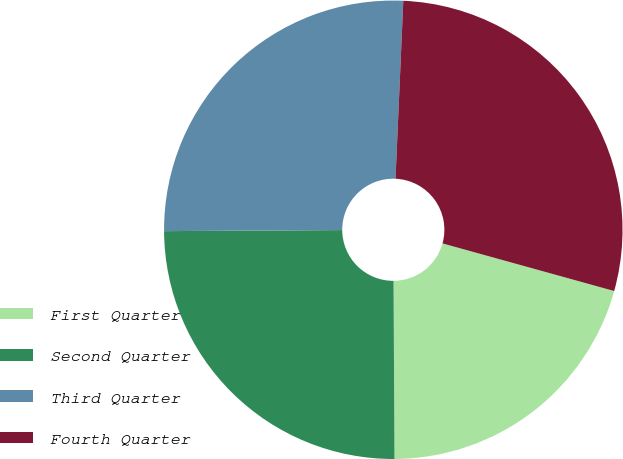<chart> <loc_0><loc_0><loc_500><loc_500><pie_chart><fcel>First Quarter<fcel>Second Quarter<fcel>Third Quarter<fcel>Fourth Quarter<nl><fcel>20.61%<fcel>24.99%<fcel>25.79%<fcel>28.61%<nl></chart> 